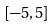Convert formula to latex. <formula><loc_0><loc_0><loc_500><loc_500>[ - 5 , 5 ]</formula> 